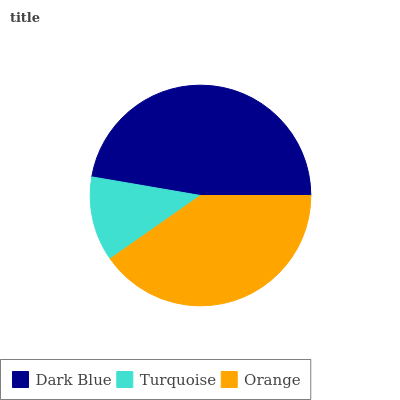Is Turquoise the minimum?
Answer yes or no. Yes. Is Dark Blue the maximum?
Answer yes or no. Yes. Is Orange the minimum?
Answer yes or no. No. Is Orange the maximum?
Answer yes or no. No. Is Orange greater than Turquoise?
Answer yes or no. Yes. Is Turquoise less than Orange?
Answer yes or no. Yes. Is Turquoise greater than Orange?
Answer yes or no. No. Is Orange less than Turquoise?
Answer yes or no. No. Is Orange the high median?
Answer yes or no. Yes. Is Orange the low median?
Answer yes or no. Yes. Is Turquoise the high median?
Answer yes or no. No. Is Dark Blue the low median?
Answer yes or no. No. 